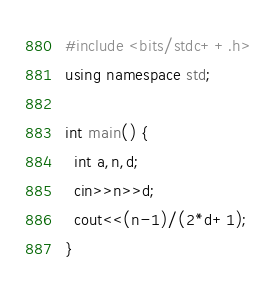Convert code to text. <code><loc_0><loc_0><loc_500><loc_500><_C++_>#include <bits/stdc++.h>
using namespace std;
 
int main() {
  int a,n,d;
  cin>>n>>d;
  cout<<(n-1)/(2*d+1);
}</code> 